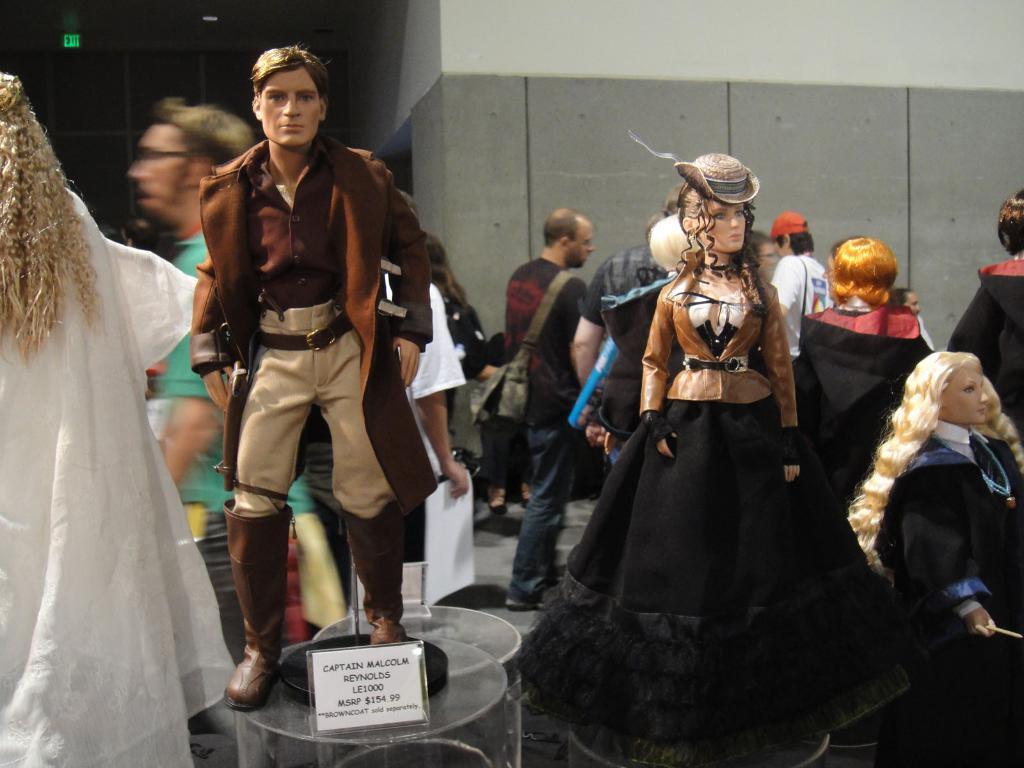Could you give a brief overview of what you see in this image? In the image we can see there are human toys kept on the table and they are wearing costumes. Behind there are people standing on the footpath. 